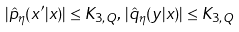<formula> <loc_0><loc_0><loc_500><loc_500>| \hat { p } _ { \eta } ( x ^ { \prime } | x ) | \leq K _ { 3 , Q } , \, | \hat { q } _ { \eta } ( y | x ) | \leq K _ { 3 , Q }</formula> 